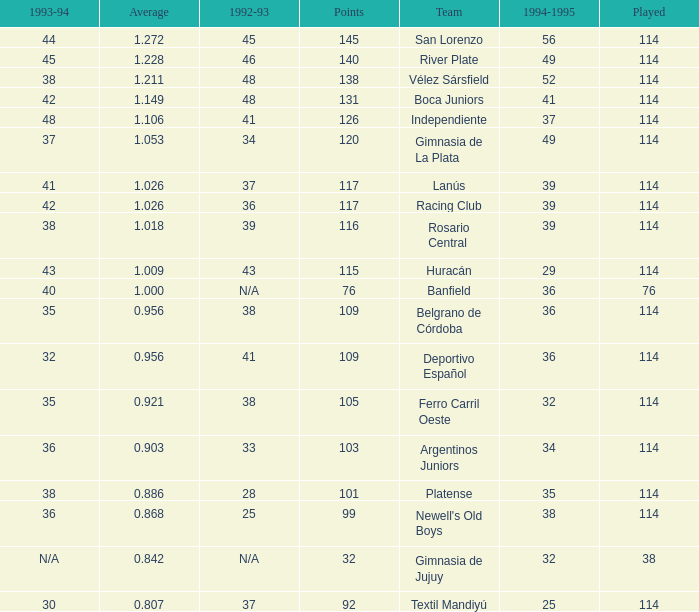Name the team for 1993-94 for 32 Deportivo Español. 